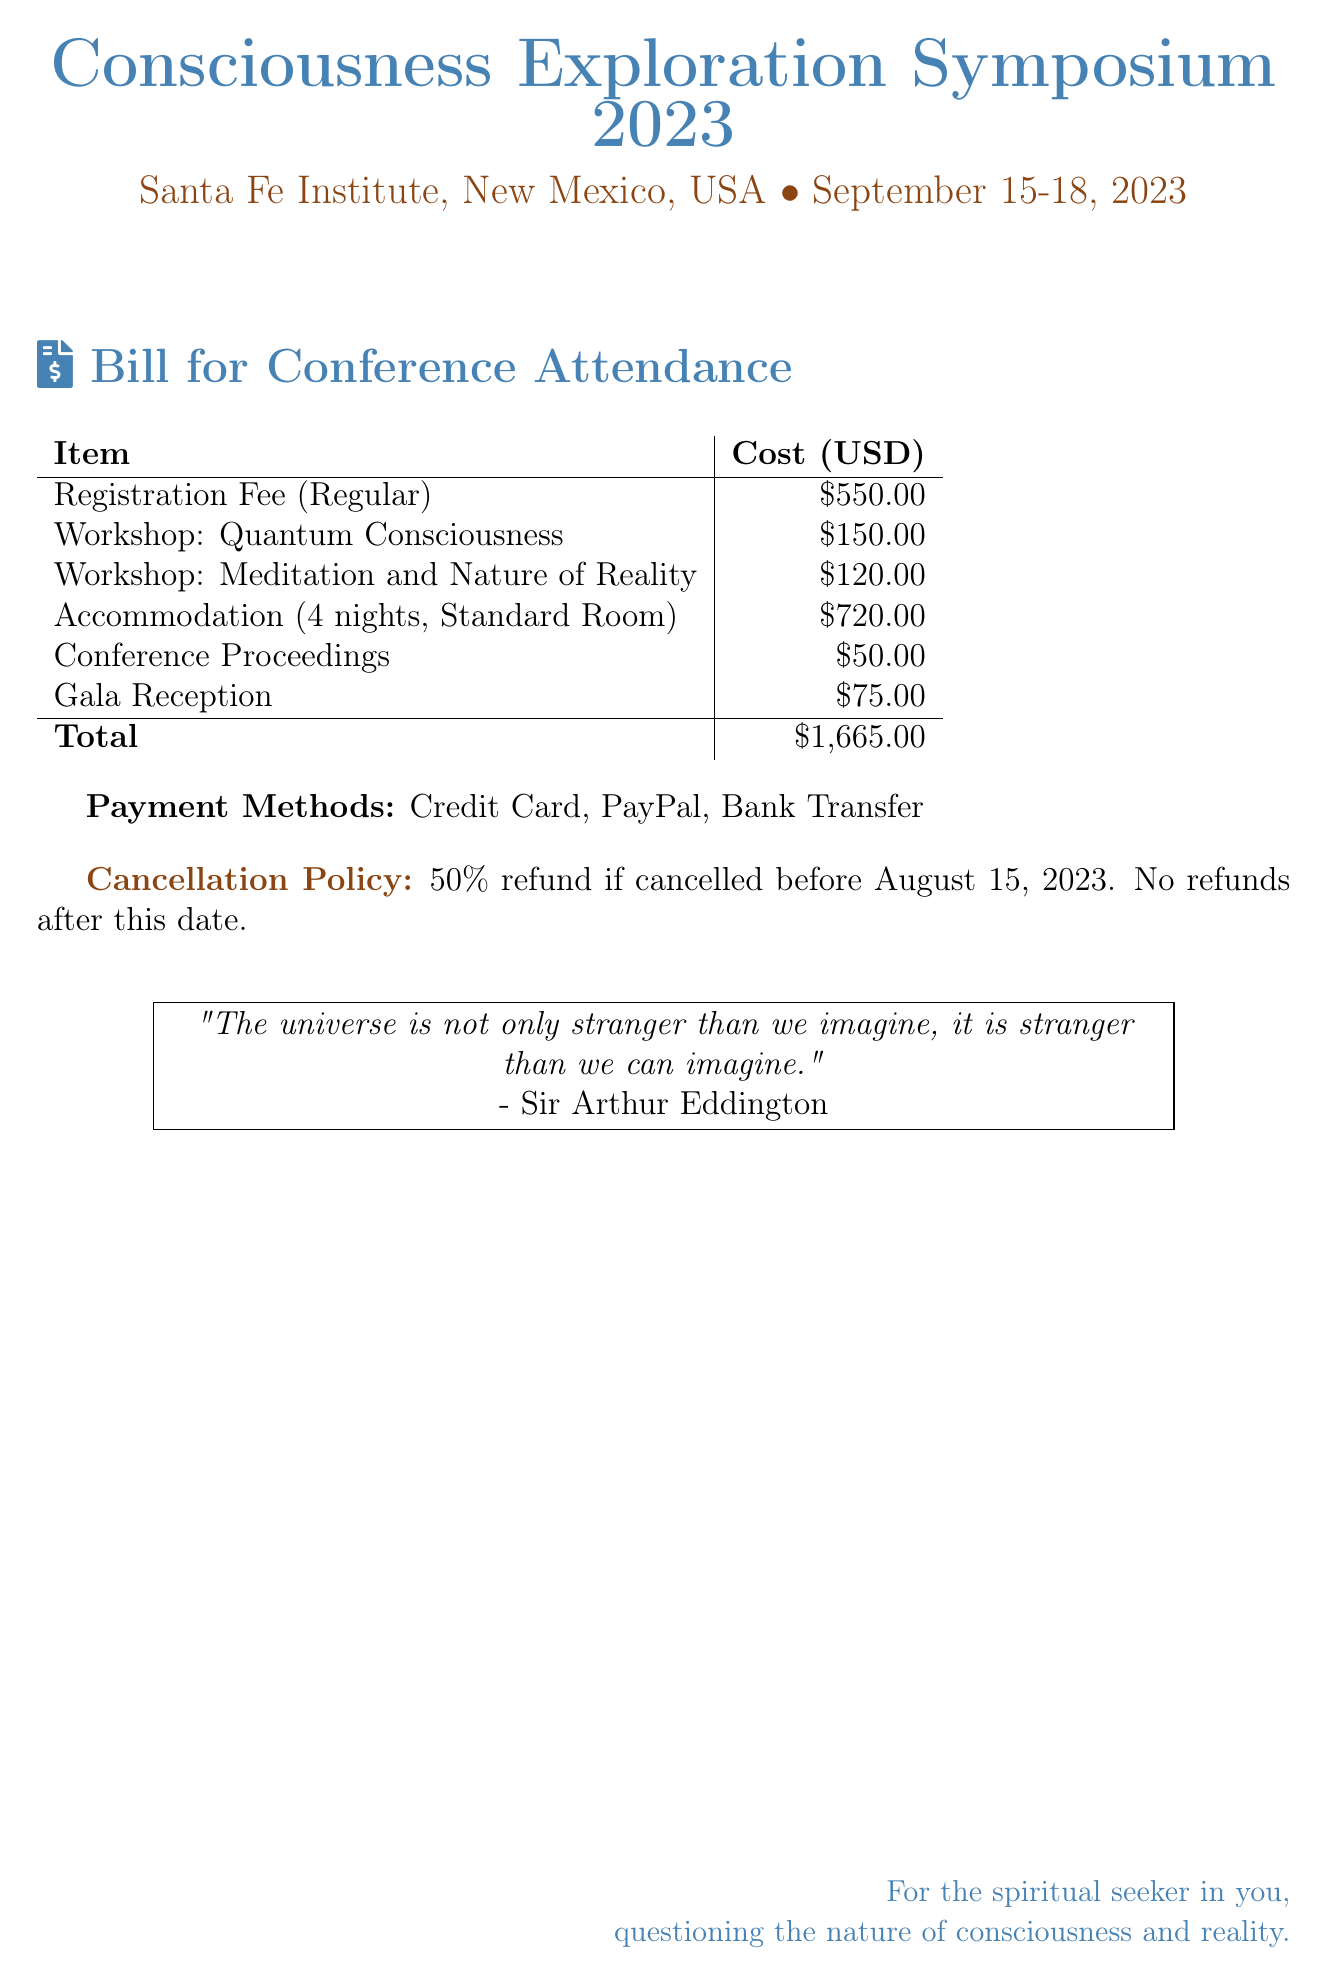What is the registration fee? The registration fee listed in the bill is a specific amount for attendance, which is $550.00.
Answer: $550.00 How much is the workshop on Quantum Consciousness? The cost of the Quantum Consciousness workshop is detailed in the document as a specific amount.
Answer: $150.00 What is the duration of accommodation charges? The accommodation charges are specified for a duration, which is outlined as 4 nights in the document.
Answer: 4 nights What is the total cost for attending the conference? The total cost is calculated by summing all individual charges listed in the document, which equals $1,665.00.
Answer: $1,665.00 Is there a refund policy mentioned? There is a cancellation policy specified in the document that includes refund conditions, indicating the details of refunds before and after a specific date.
Answer: Yes What is the deadline for receiving a refund? The deadline for receiving a refund is mentioned in relation to a specific date in the document.
Answer: August 15, 2023 How much does the Gala Reception cost? The document specifies a separate charge associated with the Gala Reception, detailing its cost.
Answer: $75.00 What payment methods are accepted? The document lists acceptable payment options for attendees to settle their bills, highlighting the alternatives available.
Answer: Credit Card, PayPal, Bank Transfer 